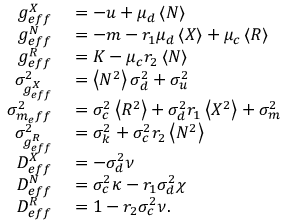<formula> <loc_0><loc_0><loc_500><loc_500>\begin{array} { r l } { g _ { e f f } ^ { X } } & = - u + \mu _ { d } \left < N \right > } \\ { g _ { e f f } ^ { N } } & = - m - r _ { 1 } \mu _ { d } \left < X \right > + \mu _ { c } \left < R \right > } \\ { g _ { e f f } ^ { R } } & = K - \mu _ { c } r _ { 2 } \left < N \right > } \\ { \sigma _ { g _ { e f f } ^ { X } } ^ { 2 } } & = \left < N ^ { 2 } \right > \sigma _ { d } ^ { 2 } + \sigma _ { u } ^ { 2 } } \\ { \sigma _ { m _ { e } f f } ^ { 2 } } & = \sigma _ { c } ^ { 2 } \left < R ^ { 2 } \right > + \sigma _ { d } ^ { 2 } { r _ { 1 } } \left < X ^ { 2 } \right > + \sigma _ { m } ^ { 2 } } \\ { \sigma _ { g _ { e f f } ^ { R } } ^ { 2 } } & = \sigma _ { k } ^ { 2 } + \sigma _ { c } ^ { 2 } { r _ { 2 } } \left < N ^ { 2 } \right > } \\ { D _ { e f f } ^ { X } } & = - \sigma _ { d } ^ { 2 } \nu } \\ { D _ { e f f } ^ { N } } & = \sigma _ { c } ^ { 2 } \kappa - r _ { 1 } \sigma _ { d } ^ { 2 } \chi } \\ { D _ { e f f } ^ { R } } & = 1 - r _ { 2 } \sigma _ { c } ^ { 2 } \nu . } \end{array}</formula> 